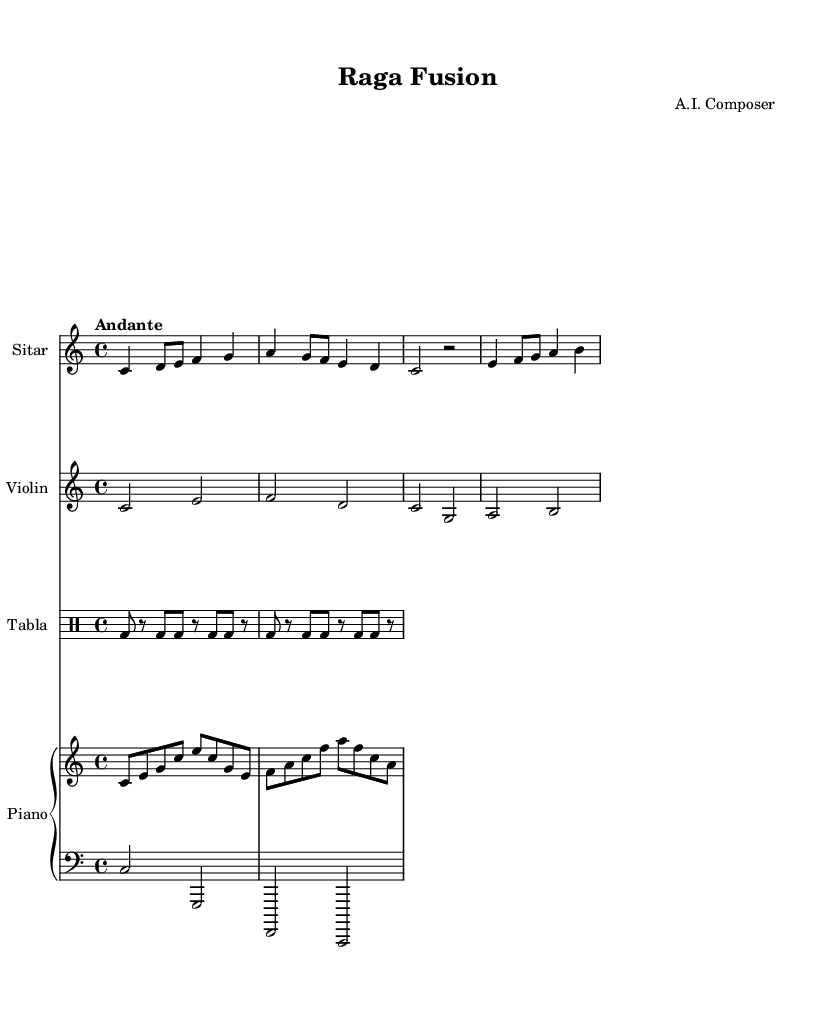What is the key signature of this music? The key signature is C major, which has no sharps or flats indicated by the absence of any sharp or flat symbols at the beginning of the staff.
Answer: C major What is the time signature of this music? The time signature is found at the beginning of the staff, where it shows four beats per measure, represented as 4/4.
Answer: 4/4 What is the tempo marking of this piece? The tempo marking is provided as "Andante," which suggests a moderately slow speed for the music.
Answer: Andante How many instruments are present in the score? The score includes a total of four different instruments: Sitar, Violin, Tabla, and Piano, indicated by separate staves for each.
Answer: Four Which instrument plays the longest note value in the first measure? The Sitar plays a quarter note in the first measure, while the Tabla plays faster notes; therefore, the Sitar has the longest value there.
Answer: Sitar What unique aspect characterizes this music as a fusion genre? The presence of traditional Indian instruments like Sitar and Tabla combined with Western instruments like Violin and Piano illustrates the fusion nature of this music style.
Answer: Fusion Which rhythmic pattern is used for the Tabla? The rhythmic pattern for the Tabla is indicated by the sequence of beats in drum notation within the given measures, showing a specific drumming pattern.
Answer: BD pattern 